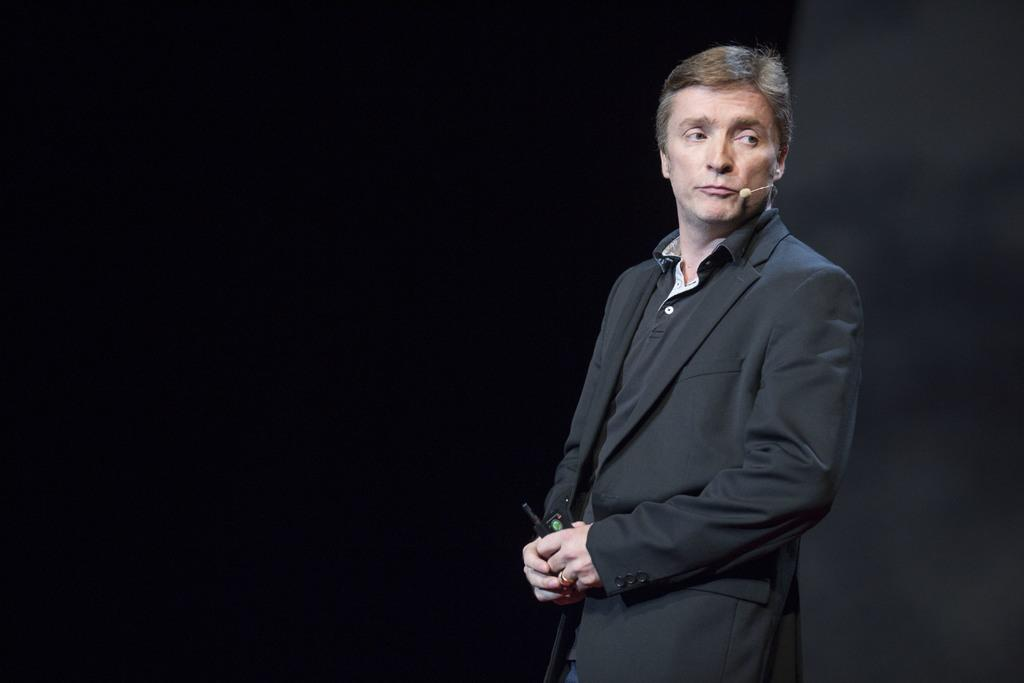Who or what is the main subject in the image? There is a person in the image. What is the person wearing? The person is wearing a microphone. What is the person holding in the image? The person is holding a black object. Can you describe the background of the image? The background of the image is dark. What type of design can be seen on the crib in the image? There is no crib present in the image. What role does the manager play in the image? There is no manager mentioned or depicted in the image. 